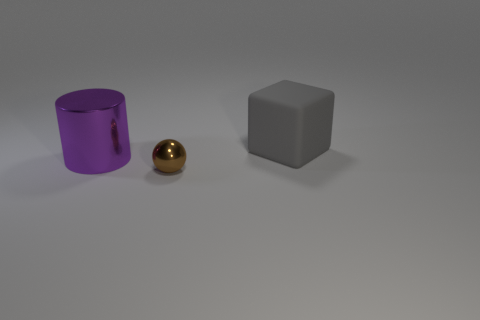Are any small objects visible?
Your answer should be very brief. Yes. Are the thing behind the large metal thing and the large cylinder made of the same material?
Give a very brief answer. No. How many gray objects have the same size as the brown metallic object?
Keep it short and to the point. 0. Are there an equal number of spheres that are in front of the ball and large gray rubber objects?
Make the answer very short. No. How many things are both in front of the purple cylinder and behind the tiny shiny sphere?
Provide a succinct answer. 0. What is the size of the thing that is made of the same material as the big cylinder?
Give a very brief answer. Small. How many other big metal things are the same shape as the brown metal thing?
Keep it short and to the point. 0. Are there more tiny brown spheres behind the purple cylinder than small things?
Provide a succinct answer. No. What is the shape of the object that is behind the shiny sphere and right of the purple cylinder?
Give a very brief answer. Cube. Do the gray matte object and the brown ball have the same size?
Ensure brevity in your answer.  No. 